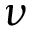Convert formula to latex. <formula><loc_0><loc_0><loc_500><loc_500>\nu</formula> 